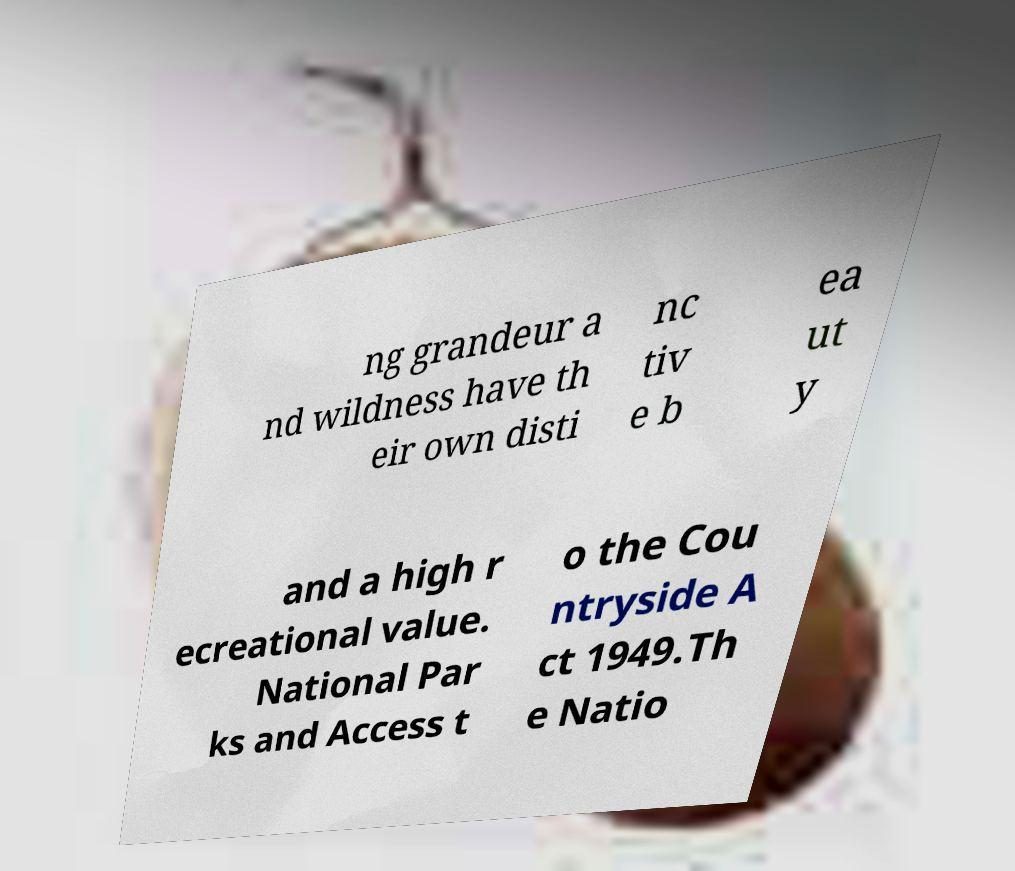Could you extract and type out the text from this image? ng grandeur a nd wildness have th eir own disti nc tiv e b ea ut y and a high r ecreational value. National Par ks and Access t o the Cou ntryside A ct 1949.Th e Natio 